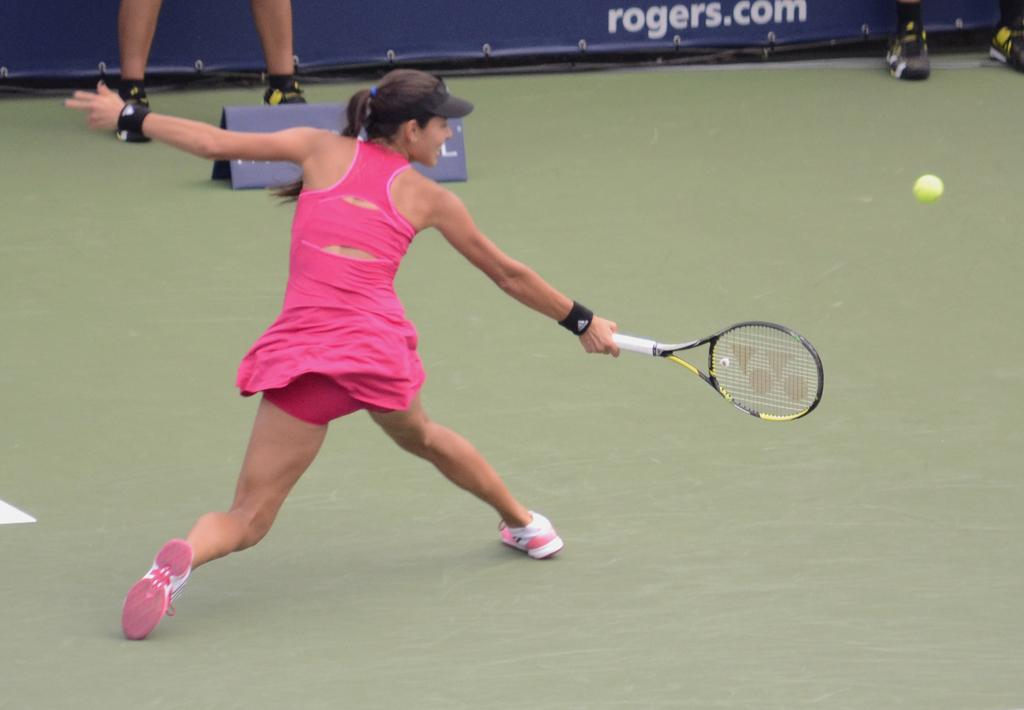What is the main activity taking place in the image? A person is playing tennis on the ground. What is the person wearing while playing tennis? The person is wearing a cap. Can you describe the location of the second person in the image? There is a person on the left side of the image. What can be seen in the background of the image? In the background, there is a banner visible, and the ground is also visible. What type of behavior is the person exhibiting with the receipt in the image? There is no receipt present in the image, so it is not possible to determine any behavior related to a receipt. 